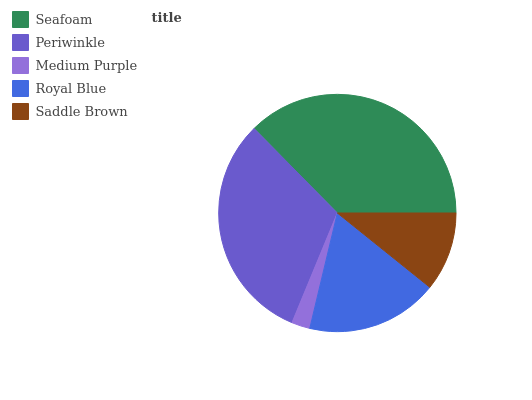Is Medium Purple the minimum?
Answer yes or no. Yes. Is Seafoam the maximum?
Answer yes or no. Yes. Is Periwinkle the minimum?
Answer yes or no. No. Is Periwinkle the maximum?
Answer yes or no. No. Is Seafoam greater than Periwinkle?
Answer yes or no. Yes. Is Periwinkle less than Seafoam?
Answer yes or no. Yes. Is Periwinkle greater than Seafoam?
Answer yes or no. No. Is Seafoam less than Periwinkle?
Answer yes or no. No. Is Royal Blue the high median?
Answer yes or no. Yes. Is Royal Blue the low median?
Answer yes or no. Yes. Is Periwinkle the high median?
Answer yes or no. No. Is Seafoam the low median?
Answer yes or no. No. 